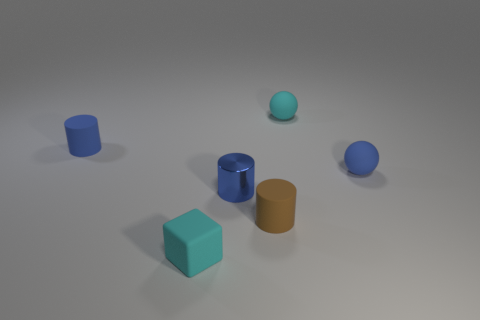What is the material of the tiny sphere that is the same color as the small cube?
Offer a very short reply. Rubber. There is a blue object behind the blue rubber ball; is there a tiny cyan matte ball to the left of it?
Offer a terse response. No. What number of things are tiny blue rubber objects that are right of the tiny cyan matte sphere or rubber spheres that are to the left of the tiny blue ball?
Ensure brevity in your answer.  2. How many things are either matte blocks or small things on the right side of the tiny cyan cube?
Offer a terse response. 5. There is a rubber cylinder that is in front of the tiny rubber cylinder to the left of the small matte cylinder that is on the right side of the metallic object; how big is it?
Give a very brief answer. Small. What material is the cyan sphere that is the same size as the blue rubber cylinder?
Provide a succinct answer. Rubber. Is there another ball that has the same size as the blue rubber ball?
Your answer should be very brief. Yes. Does the matte sphere that is behind the blue ball have the same size as the brown object?
Offer a terse response. Yes. There is a tiny object that is behind the cube and in front of the small metal object; what is its shape?
Make the answer very short. Cylinder. Are there more cyan blocks that are right of the tiny cyan sphere than cyan spheres?
Your answer should be very brief. No. 